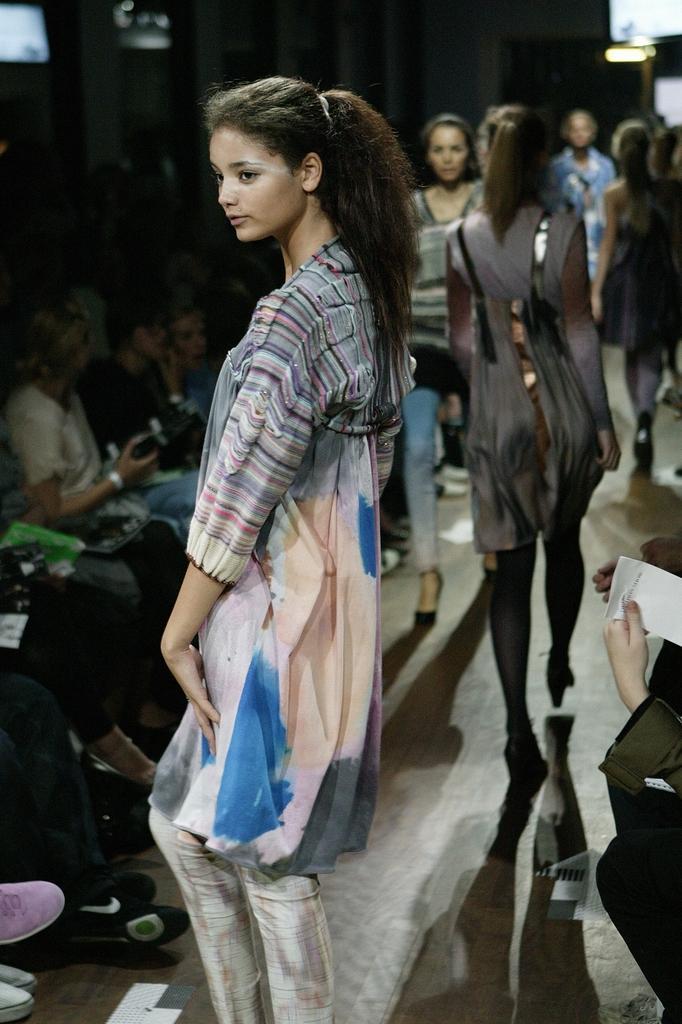How would you summarize this image in a sentence or two? In this image we can see a lady standing. In the back few are walking. Also there are many people sitting. Person on the right side is holding a paper. 